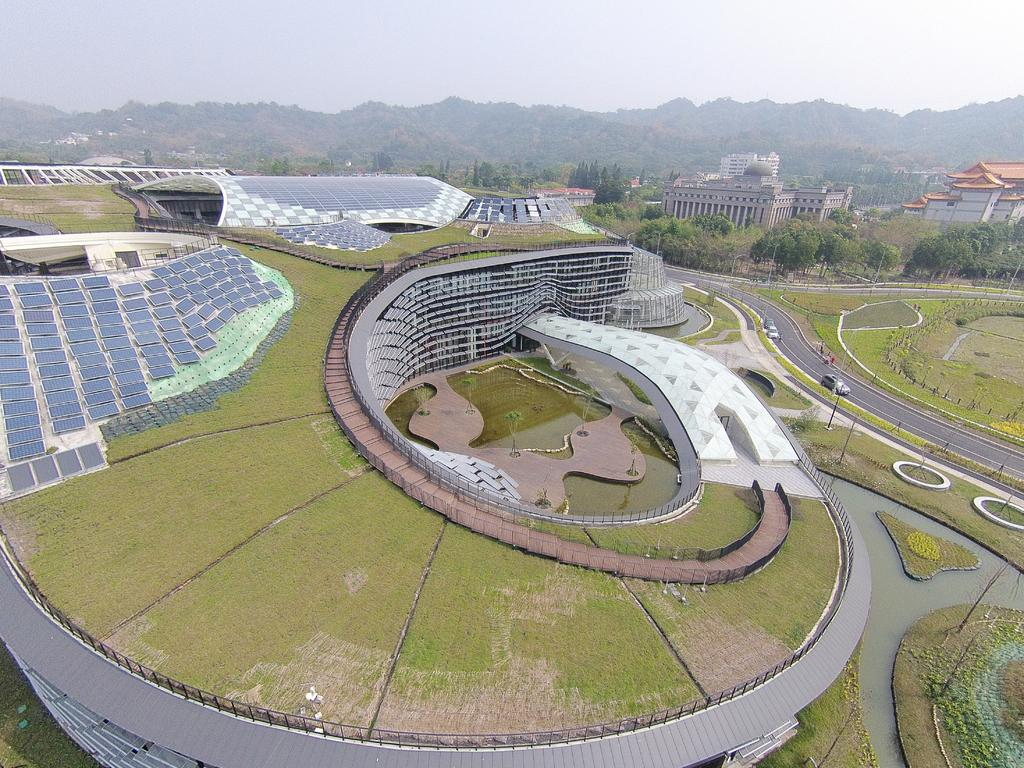What type of structures can be seen in the image? There are buildings in the image. What energy-efficient feature is present in the image? Solar panels are present in the image. What type of transportation is visible on the road? Motor vehicles are visible on the road. What type of street furniture is present in the image? Street poles are in the image. What type of vegetation is present in the image? Trees, bushes, and grass are present in the image. What type of geographical feature is present in the image? Hills are in the image. What part of the natural environment is visible in the image? The sky is visible in the image. Can you tell me how many turkeys are hiding in the cellar during the rainstorm in the image? There is no rainstorm, cellar, or turkeys present in the image. 